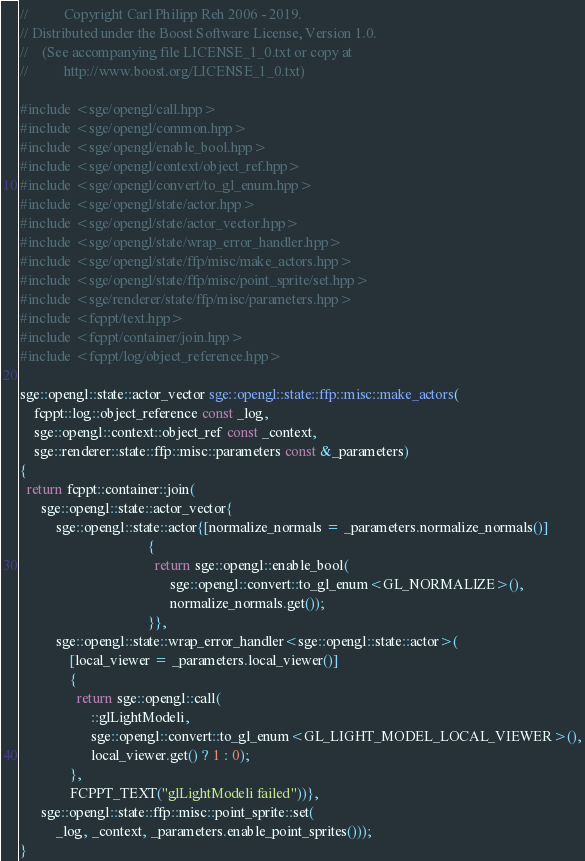<code> <loc_0><loc_0><loc_500><loc_500><_C++_>//          Copyright Carl Philipp Reh 2006 - 2019.
// Distributed under the Boost Software License, Version 1.0.
//    (See accompanying file LICENSE_1_0.txt or copy at
//          http://www.boost.org/LICENSE_1_0.txt)

#include <sge/opengl/call.hpp>
#include <sge/opengl/common.hpp>
#include <sge/opengl/enable_bool.hpp>
#include <sge/opengl/context/object_ref.hpp>
#include <sge/opengl/convert/to_gl_enum.hpp>
#include <sge/opengl/state/actor.hpp>
#include <sge/opengl/state/actor_vector.hpp>
#include <sge/opengl/state/wrap_error_handler.hpp>
#include <sge/opengl/state/ffp/misc/make_actors.hpp>
#include <sge/opengl/state/ffp/misc/point_sprite/set.hpp>
#include <sge/renderer/state/ffp/misc/parameters.hpp>
#include <fcppt/text.hpp>
#include <fcppt/container/join.hpp>
#include <fcppt/log/object_reference.hpp>

sge::opengl::state::actor_vector sge::opengl::state::ffp::misc::make_actors(
    fcppt::log::object_reference const _log,
    sge::opengl::context::object_ref const _context,
    sge::renderer::state::ffp::misc::parameters const &_parameters)
{
  return fcppt::container::join(
      sge::opengl::state::actor_vector{
          sge::opengl::state::actor{[normalize_normals = _parameters.normalize_normals()]
                                    {
                                      return sge::opengl::enable_bool(
                                          sge::opengl::convert::to_gl_enum<GL_NORMALIZE>(),
                                          normalize_normals.get());
                                    }},
          sge::opengl::state::wrap_error_handler<sge::opengl::state::actor>(
              [local_viewer = _parameters.local_viewer()]
              {
                return sge::opengl::call(
                    ::glLightModeli,
                    sge::opengl::convert::to_gl_enum<GL_LIGHT_MODEL_LOCAL_VIEWER>(),
                    local_viewer.get() ? 1 : 0);
              },
              FCPPT_TEXT("glLightModeli failed"))},
      sge::opengl::state::ffp::misc::point_sprite::set(
          _log, _context, _parameters.enable_point_sprites()));
}
</code> 